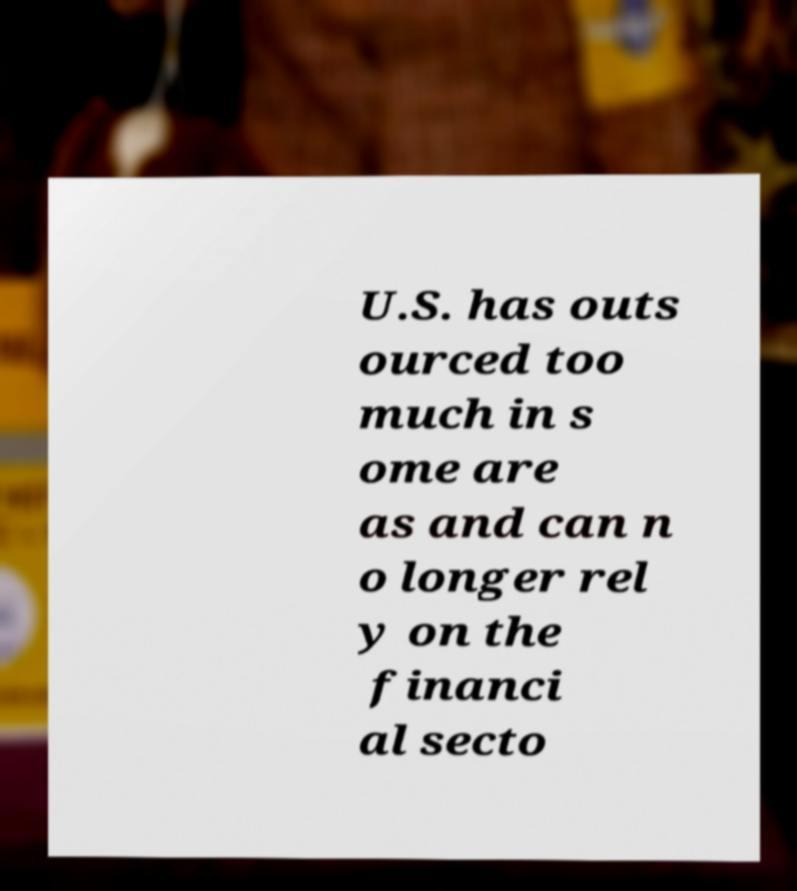Could you assist in decoding the text presented in this image and type it out clearly? U.S. has outs ourced too much in s ome are as and can n o longer rel y on the financi al secto 